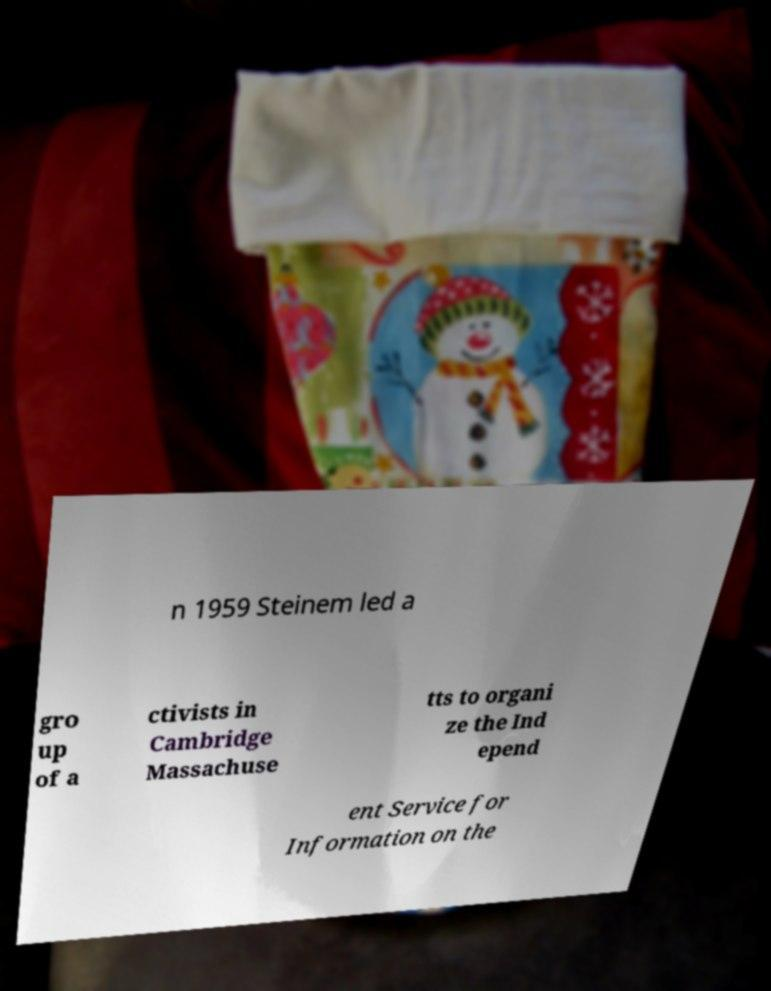Could you assist in decoding the text presented in this image and type it out clearly? n 1959 Steinem led a gro up of a ctivists in Cambridge Massachuse tts to organi ze the Ind epend ent Service for Information on the 